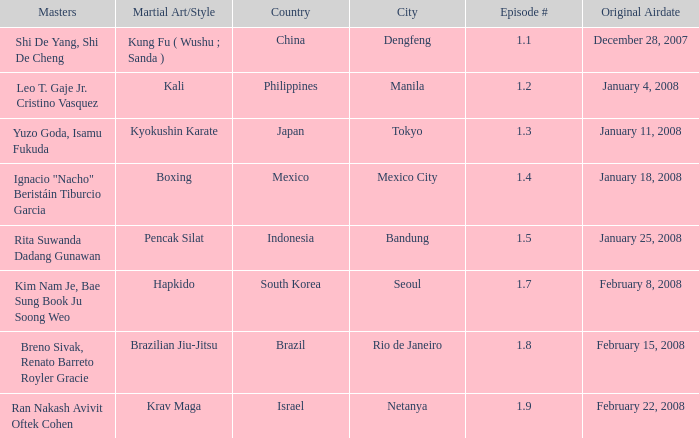Which country houses the city of netanya? Israel. 